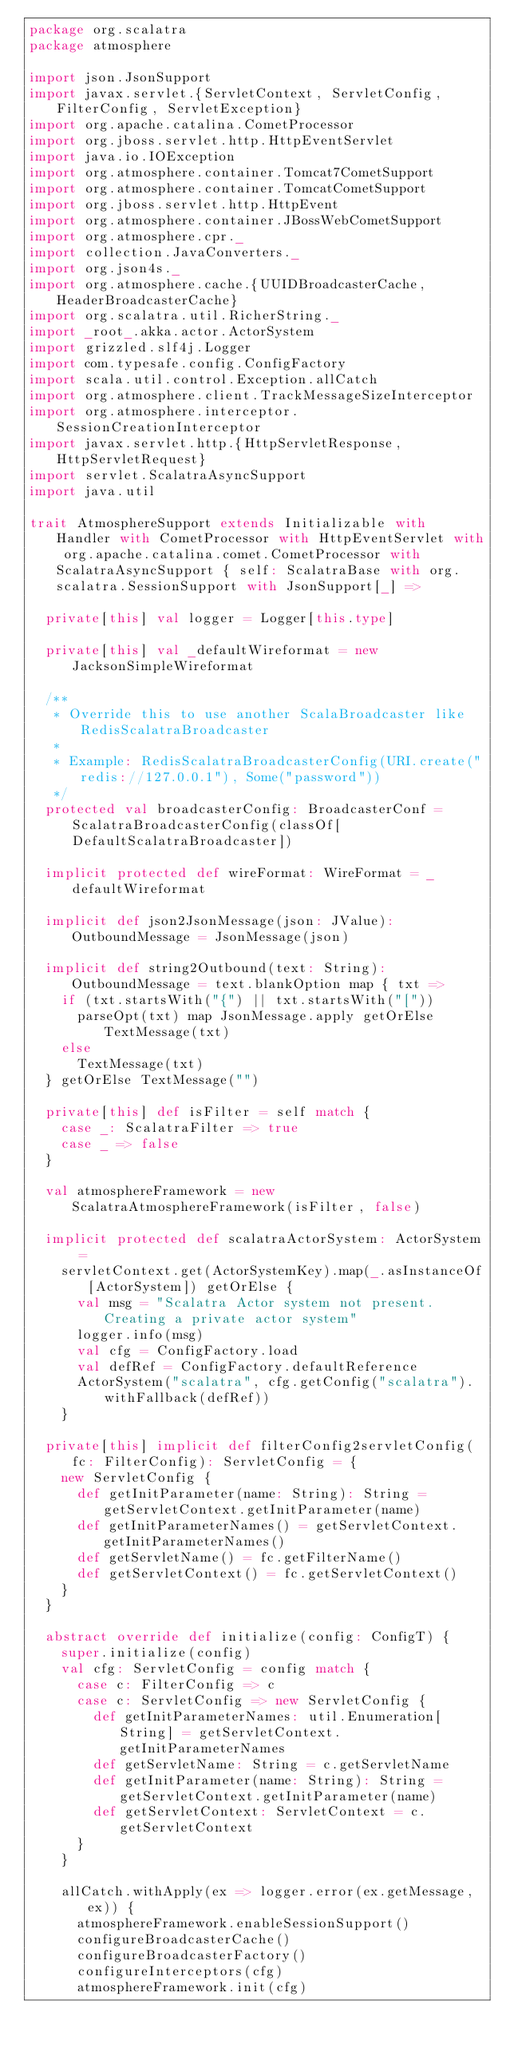Convert code to text. <code><loc_0><loc_0><loc_500><loc_500><_Scala_>package org.scalatra
package atmosphere

import json.JsonSupport
import javax.servlet.{ServletContext, ServletConfig, FilterConfig, ServletException}
import org.apache.catalina.CometProcessor
import org.jboss.servlet.http.HttpEventServlet
import java.io.IOException
import org.atmosphere.container.Tomcat7CometSupport
import org.atmosphere.container.TomcatCometSupport
import org.jboss.servlet.http.HttpEvent
import org.atmosphere.container.JBossWebCometSupport
import org.atmosphere.cpr._
import collection.JavaConverters._
import org.json4s._
import org.atmosphere.cache.{UUIDBroadcasterCache, HeaderBroadcasterCache}
import org.scalatra.util.RicherString._
import _root_.akka.actor.ActorSystem
import grizzled.slf4j.Logger
import com.typesafe.config.ConfigFactory
import scala.util.control.Exception.allCatch
import org.atmosphere.client.TrackMessageSizeInterceptor
import org.atmosphere.interceptor.SessionCreationInterceptor
import javax.servlet.http.{HttpServletResponse, HttpServletRequest}
import servlet.ScalatraAsyncSupport
import java.util

trait AtmosphereSupport extends Initializable with Handler with CometProcessor with HttpEventServlet with org.apache.catalina.comet.CometProcessor with ScalatraAsyncSupport { self: ScalatraBase with org.scalatra.SessionSupport with JsonSupport[_] =>

  private[this] val logger = Logger[this.type]

  private[this] val _defaultWireformat = new JacksonSimpleWireformat

  /**
   * Override this to use another ScalaBroadcaster like RedisScalatraBroadcaster
   *
   * Example: RedisScalatraBroadcasterConfig(URI.create("redis://127.0.0.1"), Some("password"))
   */
  protected val broadcasterConfig: BroadcasterConf = ScalatraBroadcasterConfig(classOf[DefaultScalatraBroadcaster])

  implicit protected def wireFormat: WireFormat = _defaultWireformat

  implicit def json2JsonMessage(json: JValue): OutboundMessage = JsonMessage(json)

  implicit def string2Outbound(text: String): OutboundMessage = text.blankOption map { txt =>
    if (txt.startsWith("{") || txt.startsWith("["))
      parseOpt(txt) map JsonMessage.apply getOrElse TextMessage(txt)
    else
      TextMessage(txt)
  } getOrElse TextMessage("")

  private[this] def isFilter = self match {
    case _: ScalatraFilter => true
    case _ => false
  }

  val atmosphereFramework = new ScalatraAtmosphereFramework(isFilter, false)

  implicit protected def scalatraActorSystem: ActorSystem =
    servletContext.get(ActorSystemKey).map(_.asInstanceOf[ActorSystem]) getOrElse {
      val msg = "Scalatra Actor system not present. Creating a private actor system"
      logger.info(msg)
      val cfg = ConfigFactory.load
      val defRef = ConfigFactory.defaultReference
      ActorSystem("scalatra", cfg.getConfig("scalatra").withFallback(defRef))
    }

  private[this] implicit def filterConfig2servletConfig(fc: FilterConfig): ServletConfig = {
    new ServletConfig {
      def getInitParameter(name: String): String = getServletContext.getInitParameter(name)
      def getInitParameterNames() = getServletContext.getInitParameterNames()
      def getServletName() = fc.getFilterName()
      def getServletContext() = fc.getServletContext()
    }
  }

  abstract override def initialize(config: ConfigT) {
    super.initialize(config)
    val cfg: ServletConfig = config match {
      case c: FilterConfig => c
      case c: ServletConfig => new ServletConfig {
        def getInitParameterNames: util.Enumeration[String] = getServletContext.getInitParameterNames
        def getServletName: String = c.getServletName
        def getInitParameter(name: String): String = getServletContext.getInitParameter(name)
        def getServletContext: ServletContext = c.getServletContext
      }
    }

    allCatch.withApply(ex => logger.error(ex.getMessage, ex)) {
      atmosphereFramework.enableSessionSupport()
      configureBroadcasterCache()
      configureBroadcasterFactory()
      configureInterceptors(cfg)
      atmosphereFramework.init(cfg)</code> 